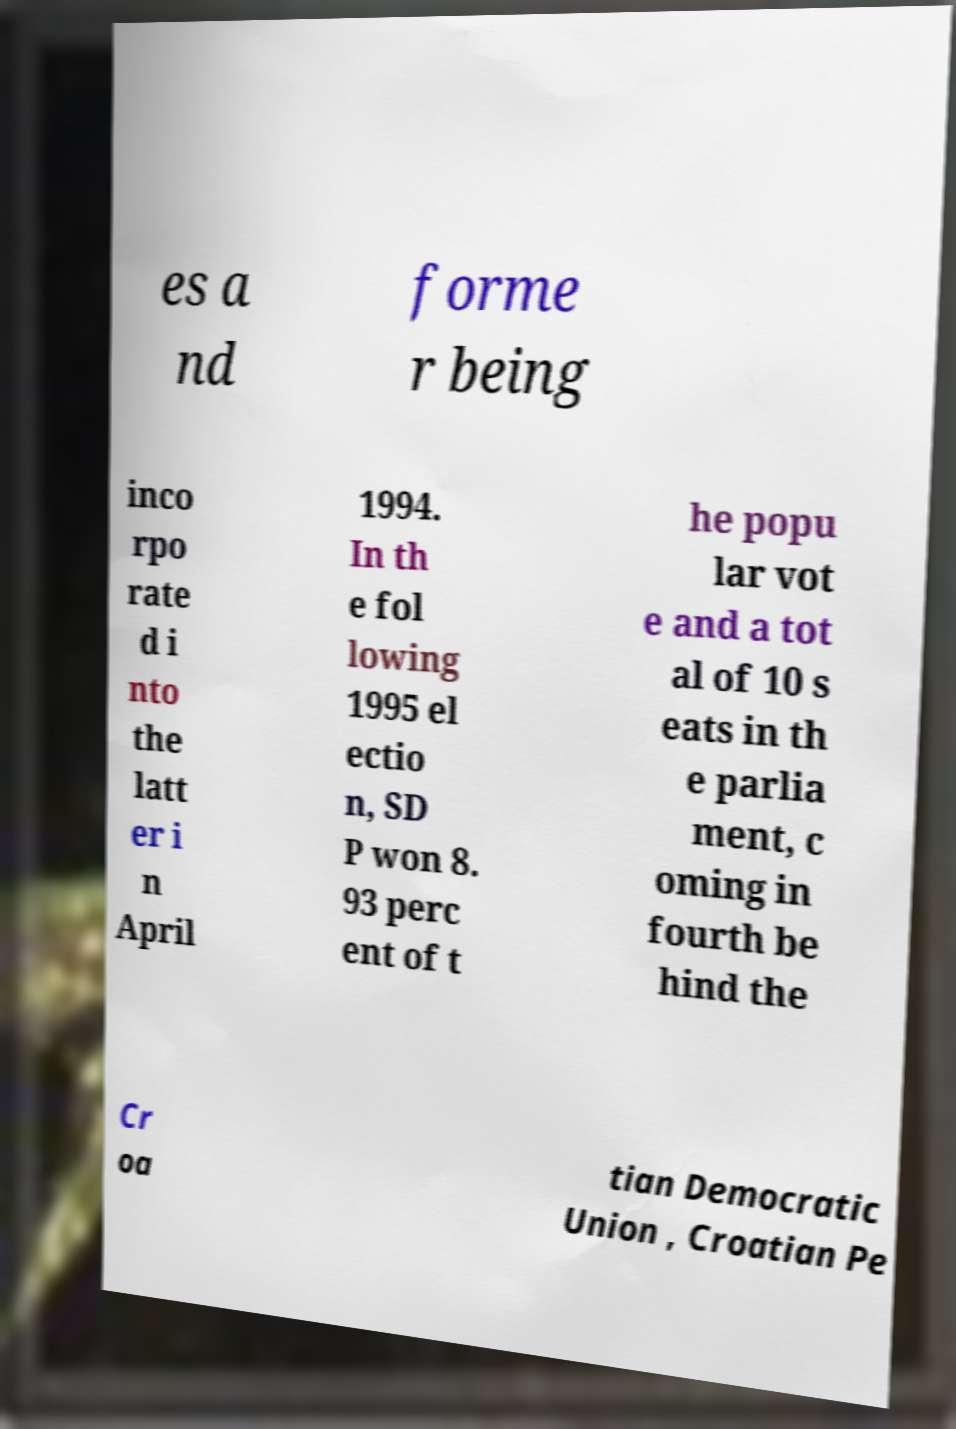Could you extract and type out the text from this image? es a nd forme r being inco rpo rate d i nto the latt er i n April 1994. In th e fol lowing 1995 el ectio n, SD P won 8. 93 perc ent of t he popu lar vot e and a tot al of 10 s eats in th e parlia ment, c oming in fourth be hind the Cr oa tian Democratic Union , Croatian Pe 